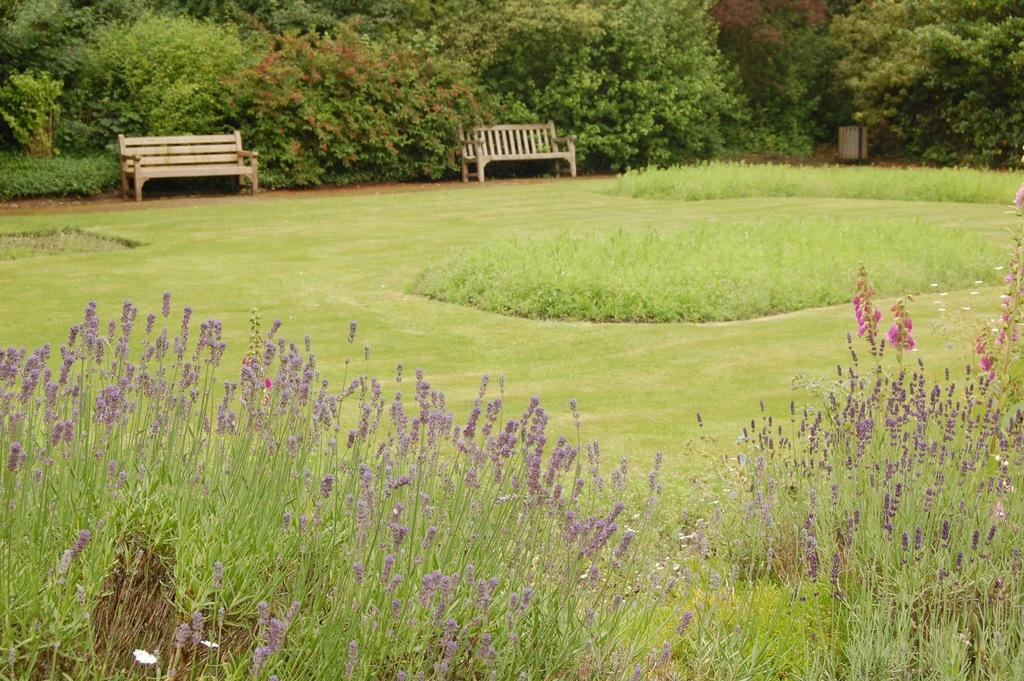What type of vegetation is at the bottom of the image? There are plants at the bottom of the image. What can be seen in the background of the image? There is grass, trees, and two benches visible in the background of the image. Can you describe the object on the right side of the image? Unfortunately, the facts provided do not give enough information to describe the object on the right side of the image. What type of boot is being used to apply cream to the trees in the image? There is no boot or cream present in the image, and the trees are not being treated with any substance. 